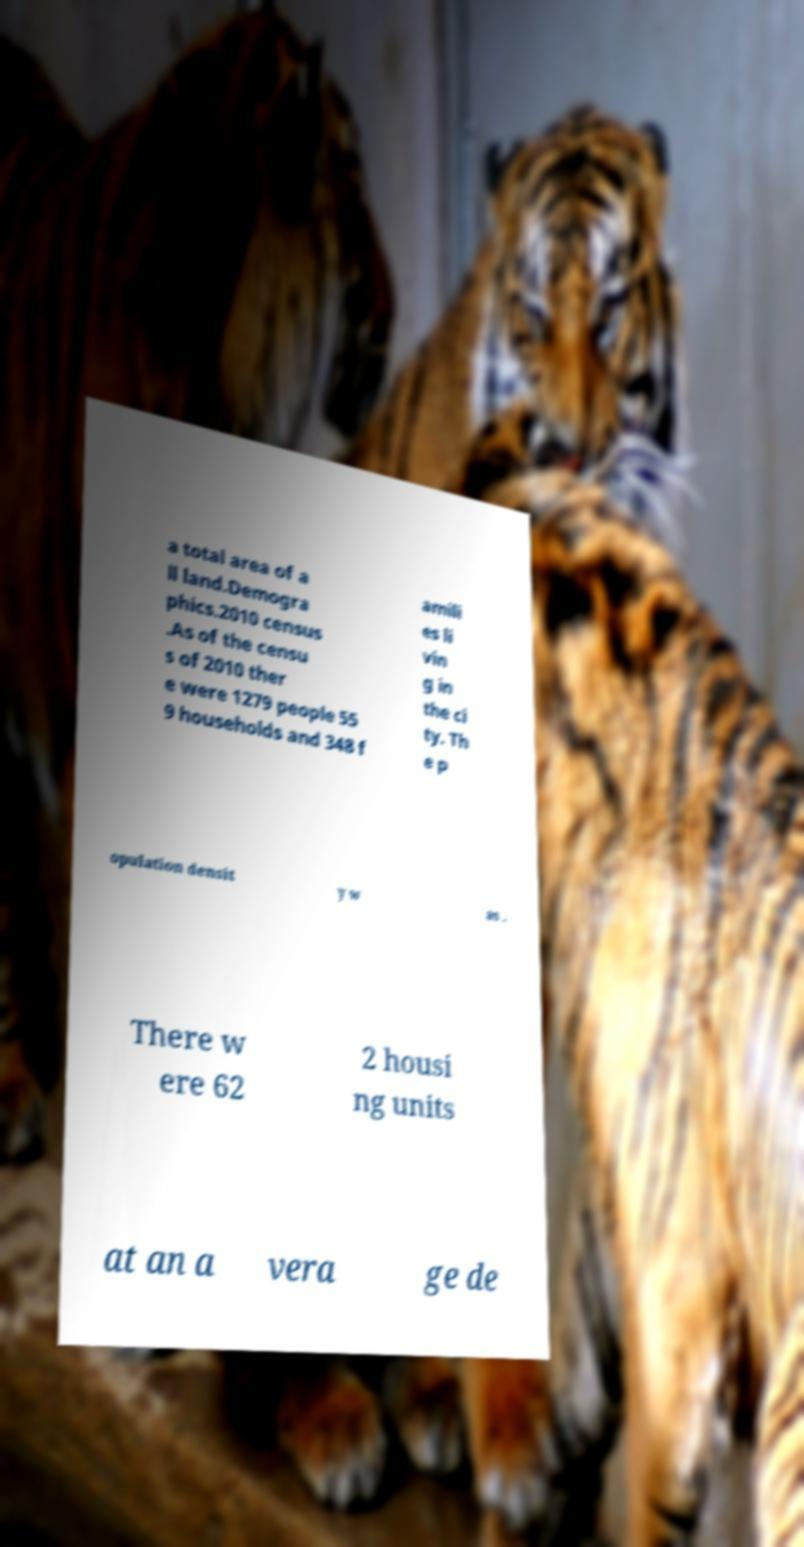Could you assist in decoding the text presented in this image and type it out clearly? a total area of a ll land.Demogra phics.2010 census .As of the censu s of 2010 ther e were 1279 people 55 9 households and 348 f amili es li vin g in the ci ty. Th e p opulation densit y w as . There w ere 62 2 housi ng units at an a vera ge de 